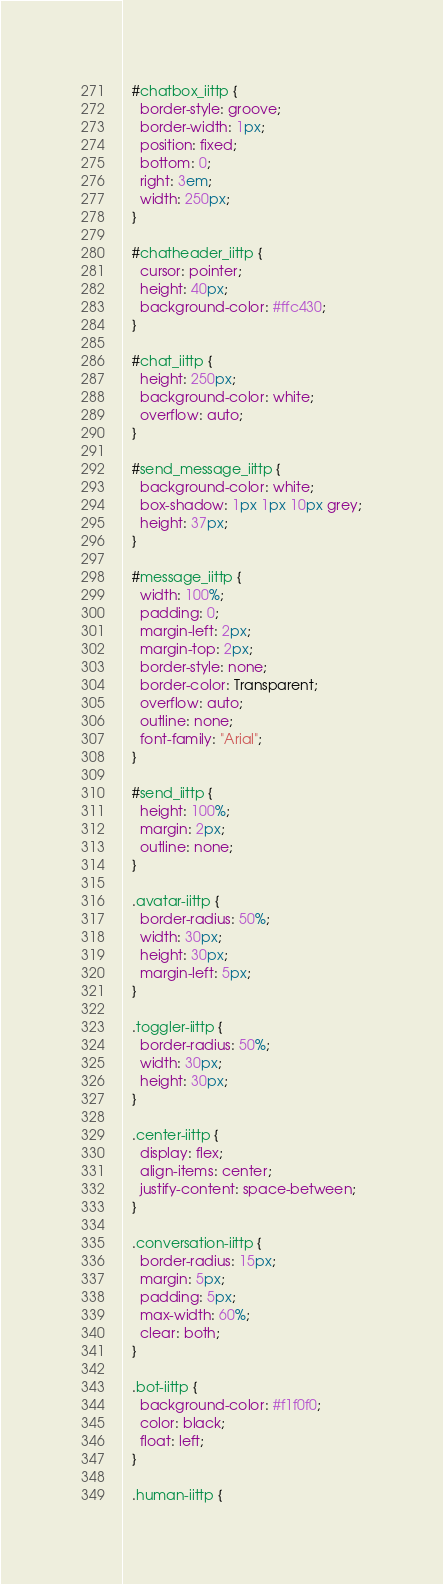Convert code to text. <code><loc_0><loc_0><loc_500><loc_500><_CSS_>  #chatbox_iittp {
    border-style: groove;
    border-width: 1px;
    position: fixed;
    bottom: 0;
    right: 3em;
    width: 250px;
  }

  #chatheader_iittp {
    cursor: pointer;
    height: 40px;
    background-color: #ffc430;
  }

  #chat_iittp {
    height: 250px;
    background-color: white;
    overflow: auto;
  }

  #send_message_iittp {
    background-color: white;
    box-shadow: 1px 1px 10px grey;
    height: 37px;
  }

  #message_iittp {
    width: 100%;
    padding: 0;
    margin-left: 2px;
    margin-top: 2px;
    border-style: none; 
    border-color: Transparent; 
    overflow: auto;
    outline: none;
    font-family: "Arial";
  }

  #send_iittp {
    height: 100%;
    margin: 2px;
    outline: none;
  }

  .avatar-iittp {
    border-radius: 50%;
    width: 30px;
    height: 30px;
    margin-left: 5px;
  }

  .toggler-iittp {
    border-radius: 50%;
    width: 30px;
    height: 30px;
  }

  .center-iittp {
    display: flex;
    align-items: center;
    justify-content: space-between;
  }
  
  .conversation-iittp {
    border-radius: 15px;
    margin: 5px;
    padding: 5px;
    max-width: 60%;
    clear: both;
  }

  .bot-iittp {
    background-color: #f1f0f0;
    color: black;
    float: left;
  }

  .human-iittp {</code> 